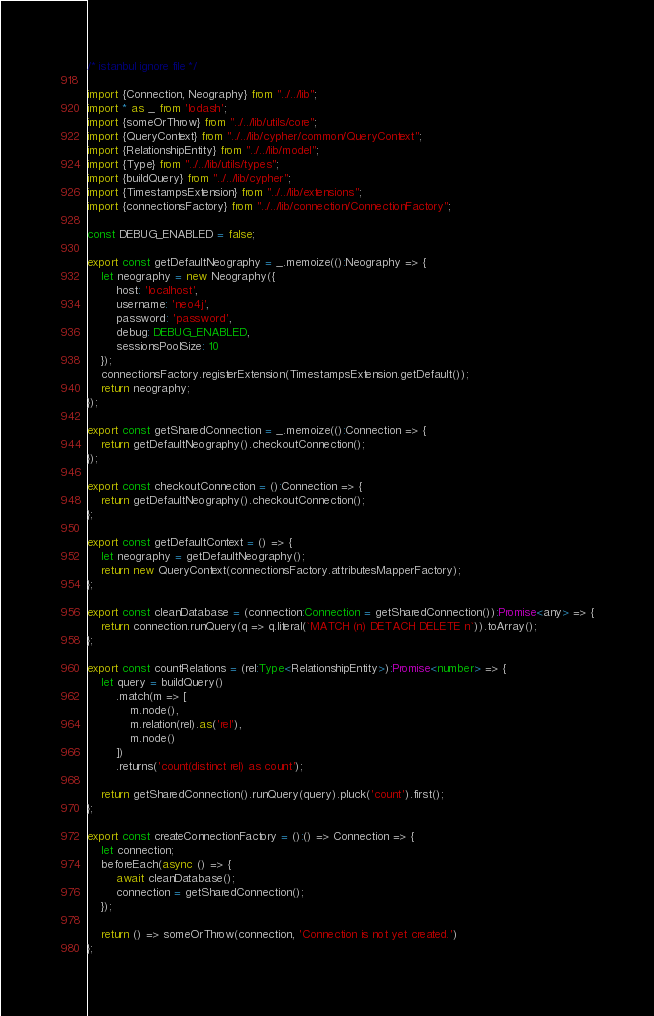<code> <loc_0><loc_0><loc_500><loc_500><_TypeScript_>/* istanbul ignore file */

import {Connection, Neography} from "../../lib";
import * as _ from 'lodash';
import {someOrThrow} from "../../lib/utils/core";
import {QueryContext} from "../../lib/cypher/common/QueryContext";
import {RelationshipEntity} from "../../lib/model";
import {Type} from "../../lib/utils/types";
import {buildQuery} from "../../lib/cypher";
import {TimestampsExtension} from "../../lib/extensions";
import {connectionsFactory} from "../../lib/connection/ConnectionFactory";

const DEBUG_ENABLED = false;

export const getDefaultNeography = _.memoize(():Neography => {
    let neography = new Neography({
        host: 'localhost',
        username: 'neo4j',
        password: 'password',
        debug: DEBUG_ENABLED,
        sessionsPoolSize: 10
    });
    connectionsFactory.registerExtension(TimestampsExtension.getDefault());
    return neography;
});

export const getSharedConnection = _.memoize(():Connection => {
    return getDefaultNeography().checkoutConnection();
});

export const checkoutConnection = ():Connection => {
    return getDefaultNeography().checkoutConnection();
};

export const getDefaultContext = () => {
    let neography = getDefaultNeography();
    return new QueryContext(connectionsFactory.attributesMapperFactory);
};

export const cleanDatabase = (connection:Connection = getSharedConnection()):Promise<any> => {
    return connection.runQuery(q => q.literal(`MATCH (n) DETACH DELETE n`)).toArray();
};

export const countRelations = (rel:Type<RelationshipEntity>):Promise<number> => {
    let query = buildQuery()
        .match(m => [
            m.node(),
            m.relation(rel).as('rel'),
            m.node()
        ])
        .returns('count(distinct rel) as count');

    return getSharedConnection().runQuery(query).pluck('count').first();
};

export const createConnectionFactory = ():() => Connection => {
    let connection;
    beforeEach(async () => {
        await cleanDatabase();
        connection = getSharedConnection();
    });

    return () => someOrThrow(connection, 'Connection is not yet created.')
};
</code> 